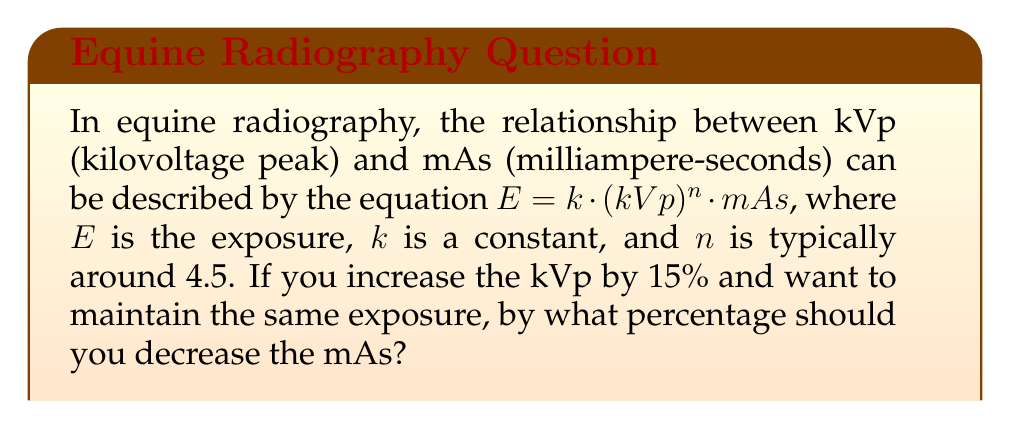Show me your answer to this math problem. Let's approach this step-by-step:

1) We start with the equation: $E = k \cdot (kVp)^n \cdot mAs$

2) We want to keep $E$ constant, so we can set up an equation:
   $k \cdot (kVp_1)^n \cdot mAs_1 = k \cdot (kVp_2)^n \cdot mAs_2$

3) The $k$ cancels out on both sides:
   $(kVp_1)^n \cdot mAs_1 = (kVp_2)^n \cdot mAs_2$

4) We know that $kVp_2 = 1.15 \cdot kVp_1$ (15% increase)

5) Substituting this in:
   $(kVp_1)^n \cdot mAs_1 = (1.15 \cdot kVp_1)^n \cdot mAs_2$

6) Simplifying:
   $mAs_1 = 1.15^n \cdot mAs_2$

7) Solving for $mAs_2$:
   $mAs_2 = \frac{mAs_1}{1.15^n}$

8) Given $n = 4.5$:
   $mAs_2 = \frac{mAs_1}{1.15^{4.5}} \approx 0.539 \cdot mAs_1$

9) This means $mAs_2$ is approximately 53.9% of $mAs_1$

10) The percentage decrease is therefore:
    $100\% - 53.9\% = 46.1\%$
Answer: 46.1% 